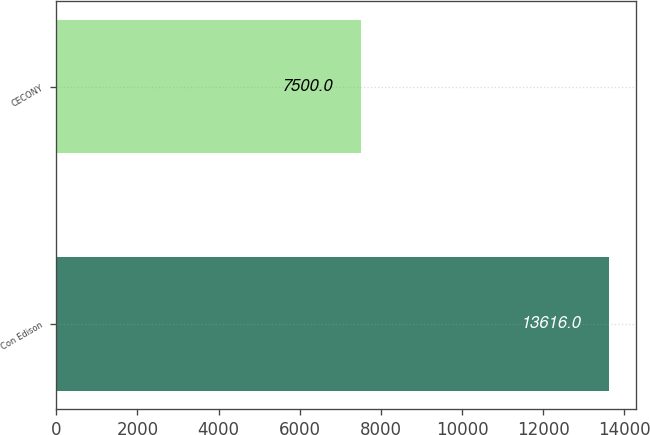<chart> <loc_0><loc_0><loc_500><loc_500><bar_chart><fcel>Con Edison<fcel>CECONY<nl><fcel>13616<fcel>7500<nl></chart> 